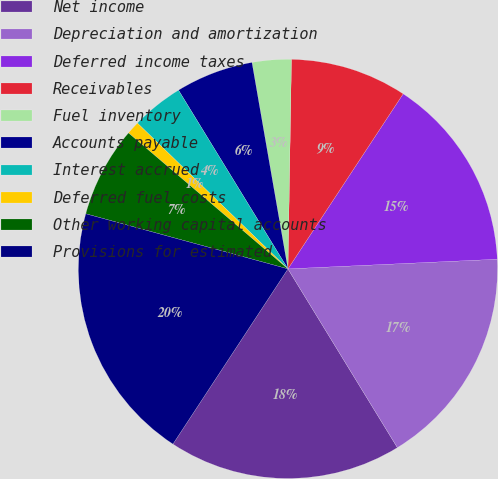Convert chart. <chart><loc_0><loc_0><loc_500><loc_500><pie_chart><fcel>Net income<fcel>Depreciation and amortization<fcel>Deferred income taxes<fcel>Receivables<fcel>Fuel inventory<fcel>Accounts payable<fcel>Interest accrued<fcel>Deferred fuel costs<fcel>Other working capital accounts<fcel>Provisions for estimated<nl><fcel>17.99%<fcel>16.99%<fcel>15.0%<fcel>9.0%<fcel>3.01%<fcel>6.0%<fcel>4.01%<fcel>1.01%<fcel>7.0%<fcel>19.99%<nl></chart> 